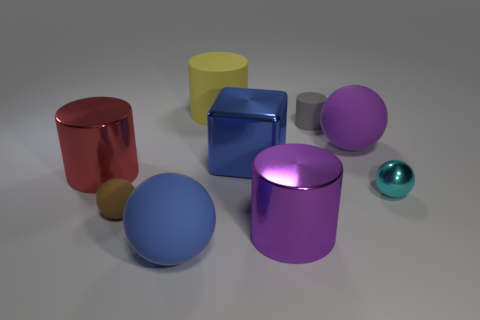There is a tiny brown thing; is it the same shape as the large object that is behind the small gray cylinder?
Offer a terse response. No. What is the size of the yellow cylinder that is the same material as the brown ball?
Give a very brief answer. Large. Is there anything else of the same color as the tiny cylinder?
Give a very brief answer. No. The large red thing in front of the large rubber ball that is behind the large cylinder that is left of the yellow thing is made of what material?
Offer a terse response. Metal. How many matte things are objects or spheres?
Your answer should be very brief. 5. Do the small metallic object and the tiny matte cylinder have the same color?
Offer a very short reply. No. Is there any other thing that has the same material as the tiny gray cylinder?
Your answer should be compact. Yes. What number of objects are either yellow shiny cylinders or cylinders in front of the big yellow matte cylinder?
Offer a terse response. 3. Do the metallic cylinder right of the blue shiny block and the large red shiny thing have the same size?
Provide a succinct answer. Yes. How many other things are there of the same shape as the blue metallic object?
Offer a terse response. 0. 